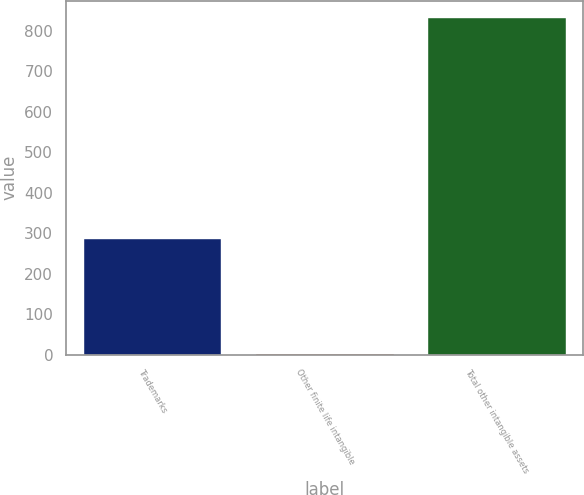Convert chart to OTSL. <chart><loc_0><loc_0><loc_500><loc_500><bar_chart><fcel>Trademarks<fcel>Other finite life intangible<fcel>Total other intangible assets<nl><fcel>285.1<fcel>1.8<fcel>832.4<nl></chart> 